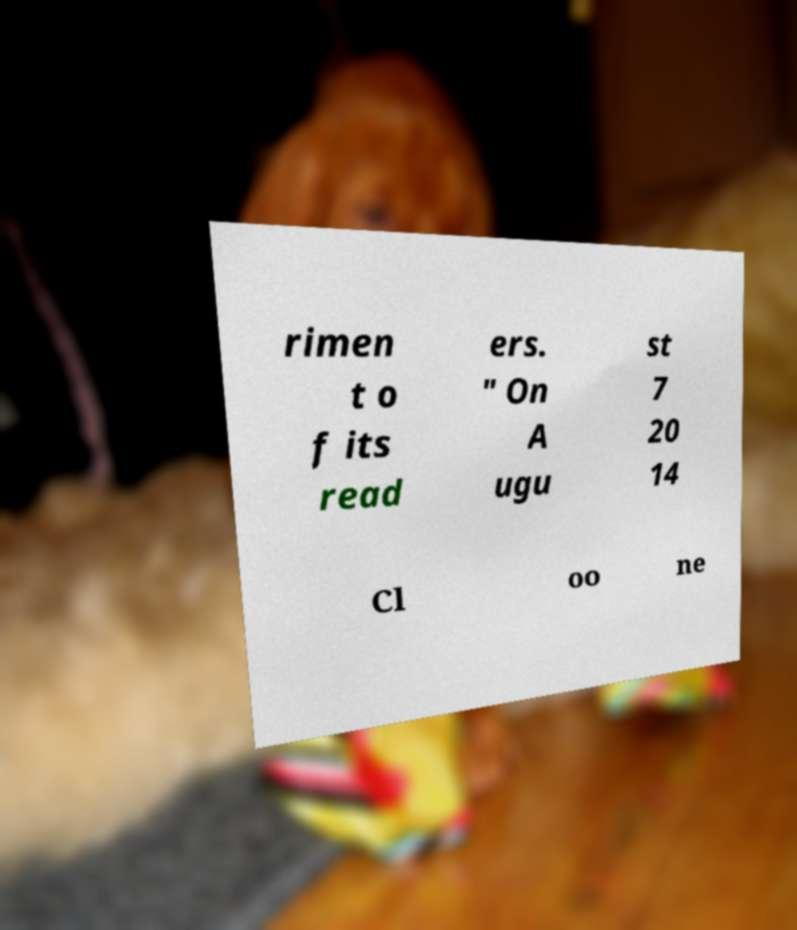Can you accurately transcribe the text from the provided image for me? rimen t o f its read ers. " On A ugu st 7 20 14 Cl oo ne 